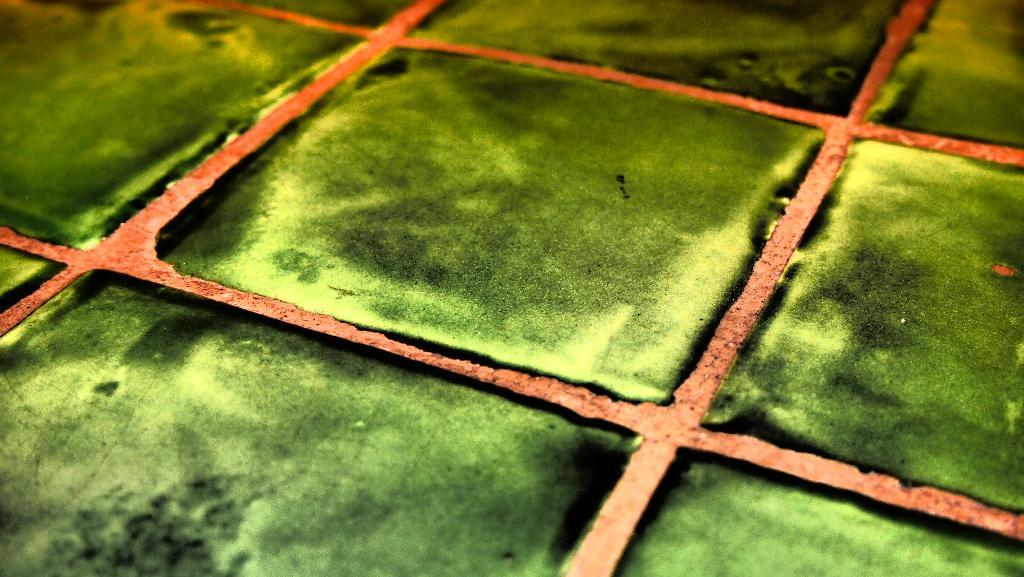What is the color of the floor in the image? The floor in the image is green in color. What type of material is the green floor made of? The green floor has tiles. What channel is the pot being used on in the image? There is no television or channel present in the image, and therefore no pot being used on a channel. 